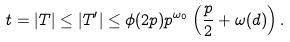Convert formula to latex. <formula><loc_0><loc_0><loc_500><loc_500>t = | T | \leq | T ^ { \prime } | \leq \phi ( 2 p ) p ^ { \omega _ { 0 } } \left ( \frac { p } { 2 } + \omega ( d ) \right ) .</formula> 